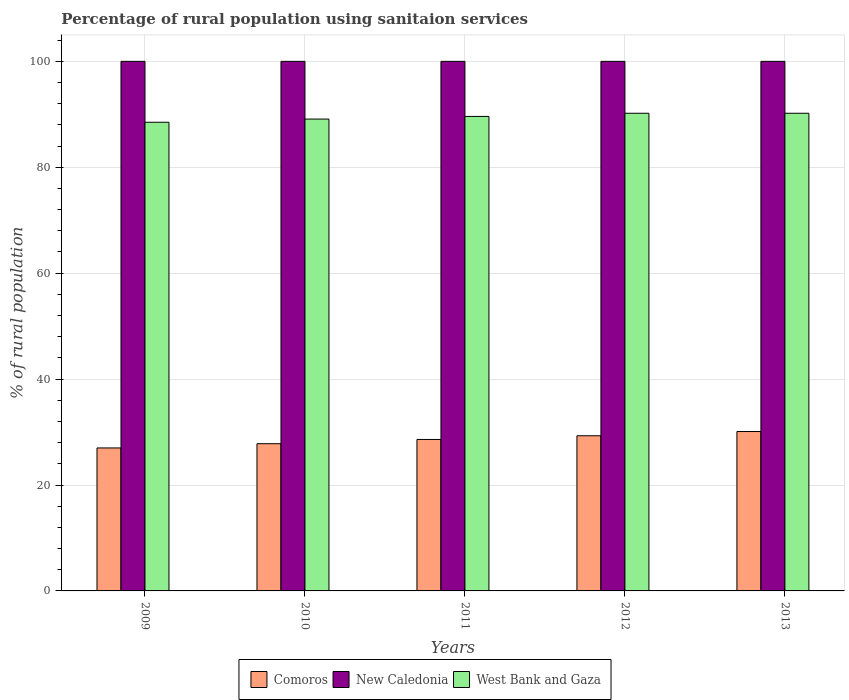Are the number of bars per tick equal to the number of legend labels?
Offer a terse response. Yes. How many bars are there on the 2nd tick from the right?
Offer a terse response. 3. In how many cases, is the number of bars for a given year not equal to the number of legend labels?
Your response must be concise. 0. What is the percentage of rural population using sanitaion services in New Caledonia in 2009?
Your response must be concise. 100. Across all years, what is the maximum percentage of rural population using sanitaion services in West Bank and Gaza?
Keep it short and to the point. 90.2. Across all years, what is the minimum percentage of rural population using sanitaion services in Comoros?
Provide a short and direct response. 27. In which year was the percentage of rural population using sanitaion services in West Bank and Gaza maximum?
Offer a very short reply. 2012. In which year was the percentage of rural population using sanitaion services in New Caledonia minimum?
Your response must be concise. 2009. What is the total percentage of rural population using sanitaion services in Comoros in the graph?
Provide a short and direct response. 142.8. What is the difference between the percentage of rural population using sanitaion services in Comoros in 2011 and that in 2012?
Offer a terse response. -0.7. What is the difference between the percentage of rural population using sanitaion services in Comoros in 2011 and the percentage of rural population using sanitaion services in West Bank and Gaza in 2013?
Give a very brief answer. -61.6. What is the average percentage of rural population using sanitaion services in West Bank and Gaza per year?
Offer a very short reply. 89.52. In the year 2013, what is the difference between the percentage of rural population using sanitaion services in New Caledonia and percentage of rural population using sanitaion services in West Bank and Gaza?
Provide a short and direct response. 9.8. In how many years, is the percentage of rural population using sanitaion services in Comoros greater than 80 %?
Ensure brevity in your answer.  0. What is the ratio of the percentage of rural population using sanitaion services in West Bank and Gaza in 2011 to that in 2013?
Offer a very short reply. 0.99. Is the percentage of rural population using sanitaion services in Comoros in 2010 less than that in 2013?
Keep it short and to the point. Yes. Is the difference between the percentage of rural population using sanitaion services in New Caledonia in 2011 and 2012 greater than the difference between the percentage of rural population using sanitaion services in West Bank and Gaza in 2011 and 2012?
Make the answer very short. Yes. What is the difference between the highest and the second highest percentage of rural population using sanitaion services in West Bank and Gaza?
Keep it short and to the point. 0. What is the difference between the highest and the lowest percentage of rural population using sanitaion services in Comoros?
Provide a succinct answer. 3.1. What does the 2nd bar from the left in 2010 represents?
Your answer should be compact. New Caledonia. What does the 3rd bar from the right in 2013 represents?
Ensure brevity in your answer.  Comoros. Is it the case that in every year, the sum of the percentage of rural population using sanitaion services in Comoros and percentage of rural population using sanitaion services in West Bank and Gaza is greater than the percentage of rural population using sanitaion services in New Caledonia?
Your answer should be very brief. Yes. How many bars are there?
Ensure brevity in your answer.  15. How many years are there in the graph?
Ensure brevity in your answer.  5. How many legend labels are there?
Your response must be concise. 3. How are the legend labels stacked?
Provide a succinct answer. Horizontal. What is the title of the graph?
Provide a succinct answer. Percentage of rural population using sanitaion services. Does "Korea (Republic)" appear as one of the legend labels in the graph?
Keep it short and to the point. No. What is the label or title of the Y-axis?
Make the answer very short. % of rural population. What is the % of rural population of New Caledonia in 2009?
Your answer should be very brief. 100. What is the % of rural population in West Bank and Gaza in 2009?
Ensure brevity in your answer.  88.5. What is the % of rural population of Comoros in 2010?
Keep it short and to the point. 27.8. What is the % of rural population of West Bank and Gaza in 2010?
Make the answer very short. 89.1. What is the % of rural population in Comoros in 2011?
Offer a terse response. 28.6. What is the % of rural population in New Caledonia in 2011?
Keep it short and to the point. 100. What is the % of rural population of West Bank and Gaza in 2011?
Provide a succinct answer. 89.6. What is the % of rural population in Comoros in 2012?
Offer a very short reply. 29.3. What is the % of rural population of New Caledonia in 2012?
Your response must be concise. 100. What is the % of rural population of West Bank and Gaza in 2012?
Ensure brevity in your answer.  90.2. What is the % of rural population of Comoros in 2013?
Keep it short and to the point. 30.1. What is the % of rural population of West Bank and Gaza in 2013?
Offer a very short reply. 90.2. Across all years, what is the maximum % of rural population of Comoros?
Give a very brief answer. 30.1. Across all years, what is the maximum % of rural population of New Caledonia?
Your answer should be compact. 100. Across all years, what is the maximum % of rural population of West Bank and Gaza?
Make the answer very short. 90.2. Across all years, what is the minimum % of rural population in Comoros?
Make the answer very short. 27. Across all years, what is the minimum % of rural population of New Caledonia?
Your answer should be very brief. 100. Across all years, what is the minimum % of rural population of West Bank and Gaza?
Make the answer very short. 88.5. What is the total % of rural population of Comoros in the graph?
Your answer should be very brief. 142.8. What is the total % of rural population of New Caledonia in the graph?
Keep it short and to the point. 500. What is the total % of rural population in West Bank and Gaza in the graph?
Your answer should be compact. 447.6. What is the difference between the % of rural population in Comoros in 2009 and that in 2010?
Keep it short and to the point. -0.8. What is the difference between the % of rural population in West Bank and Gaza in 2009 and that in 2010?
Provide a succinct answer. -0.6. What is the difference between the % of rural population of New Caledonia in 2009 and that in 2011?
Your answer should be compact. 0. What is the difference between the % of rural population of West Bank and Gaza in 2009 and that in 2011?
Provide a succinct answer. -1.1. What is the difference between the % of rural population in Comoros in 2009 and that in 2012?
Make the answer very short. -2.3. What is the difference between the % of rural population of Comoros in 2009 and that in 2013?
Offer a very short reply. -3.1. What is the difference between the % of rural population of New Caledonia in 2009 and that in 2013?
Provide a short and direct response. 0. What is the difference between the % of rural population of West Bank and Gaza in 2009 and that in 2013?
Your answer should be very brief. -1.7. What is the difference between the % of rural population of New Caledonia in 2010 and that in 2011?
Provide a succinct answer. 0. What is the difference between the % of rural population of West Bank and Gaza in 2010 and that in 2011?
Give a very brief answer. -0.5. What is the difference between the % of rural population in Comoros in 2010 and that in 2012?
Offer a very short reply. -1.5. What is the difference between the % of rural population in West Bank and Gaza in 2010 and that in 2012?
Keep it short and to the point. -1.1. What is the difference between the % of rural population in New Caledonia in 2010 and that in 2013?
Make the answer very short. 0. What is the difference between the % of rural population of West Bank and Gaza in 2011 and that in 2012?
Your response must be concise. -0.6. What is the difference between the % of rural population of West Bank and Gaza in 2011 and that in 2013?
Offer a terse response. -0.6. What is the difference between the % of rural population of Comoros in 2009 and the % of rural population of New Caledonia in 2010?
Your answer should be very brief. -73. What is the difference between the % of rural population in Comoros in 2009 and the % of rural population in West Bank and Gaza in 2010?
Keep it short and to the point. -62.1. What is the difference between the % of rural population in New Caledonia in 2009 and the % of rural population in West Bank and Gaza in 2010?
Provide a short and direct response. 10.9. What is the difference between the % of rural population of Comoros in 2009 and the % of rural population of New Caledonia in 2011?
Your answer should be very brief. -73. What is the difference between the % of rural population of Comoros in 2009 and the % of rural population of West Bank and Gaza in 2011?
Keep it short and to the point. -62.6. What is the difference between the % of rural population in Comoros in 2009 and the % of rural population in New Caledonia in 2012?
Keep it short and to the point. -73. What is the difference between the % of rural population of Comoros in 2009 and the % of rural population of West Bank and Gaza in 2012?
Offer a very short reply. -63.2. What is the difference between the % of rural population of New Caledonia in 2009 and the % of rural population of West Bank and Gaza in 2012?
Your answer should be very brief. 9.8. What is the difference between the % of rural population in Comoros in 2009 and the % of rural population in New Caledonia in 2013?
Give a very brief answer. -73. What is the difference between the % of rural population of Comoros in 2009 and the % of rural population of West Bank and Gaza in 2013?
Your response must be concise. -63.2. What is the difference between the % of rural population of New Caledonia in 2009 and the % of rural population of West Bank and Gaza in 2013?
Ensure brevity in your answer.  9.8. What is the difference between the % of rural population of Comoros in 2010 and the % of rural population of New Caledonia in 2011?
Offer a very short reply. -72.2. What is the difference between the % of rural population of Comoros in 2010 and the % of rural population of West Bank and Gaza in 2011?
Offer a very short reply. -61.8. What is the difference between the % of rural population in Comoros in 2010 and the % of rural population in New Caledonia in 2012?
Ensure brevity in your answer.  -72.2. What is the difference between the % of rural population of Comoros in 2010 and the % of rural population of West Bank and Gaza in 2012?
Your answer should be very brief. -62.4. What is the difference between the % of rural population of Comoros in 2010 and the % of rural population of New Caledonia in 2013?
Provide a succinct answer. -72.2. What is the difference between the % of rural population in Comoros in 2010 and the % of rural population in West Bank and Gaza in 2013?
Your answer should be compact. -62.4. What is the difference between the % of rural population of Comoros in 2011 and the % of rural population of New Caledonia in 2012?
Your answer should be very brief. -71.4. What is the difference between the % of rural population of Comoros in 2011 and the % of rural population of West Bank and Gaza in 2012?
Make the answer very short. -61.6. What is the difference between the % of rural population in Comoros in 2011 and the % of rural population in New Caledonia in 2013?
Ensure brevity in your answer.  -71.4. What is the difference between the % of rural population in Comoros in 2011 and the % of rural population in West Bank and Gaza in 2013?
Provide a succinct answer. -61.6. What is the difference between the % of rural population of New Caledonia in 2011 and the % of rural population of West Bank and Gaza in 2013?
Provide a succinct answer. 9.8. What is the difference between the % of rural population of Comoros in 2012 and the % of rural population of New Caledonia in 2013?
Give a very brief answer. -70.7. What is the difference between the % of rural population of Comoros in 2012 and the % of rural population of West Bank and Gaza in 2013?
Make the answer very short. -60.9. What is the difference between the % of rural population in New Caledonia in 2012 and the % of rural population in West Bank and Gaza in 2013?
Offer a terse response. 9.8. What is the average % of rural population in Comoros per year?
Keep it short and to the point. 28.56. What is the average % of rural population in West Bank and Gaza per year?
Keep it short and to the point. 89.52. In the year 2009, what is the difference between the % of rural population in Comoros and % of rural population in New Caledonia?
Provide a short and direct response. -73. In the year 2009, what is the difference between the % of rural population in Comoros and % of rural population in West Bank and Gaza?
Your answer should be compact. -61.5. In the year 2009, what is the difference between the % of rural population of New Caledonia and % of rural population of West Bank and Gaza?
Give a very brief answer. 11.5. In the year 2010, what is the difference between the % of rural population in Comoros and % of rural population in New Caledonia?
Offer a terse response. -72.2. In the year 2010, what is the difference between the % of rural population of Comoros and % of rural population of West Bank and Gaza?
Offer a terse response. -61.3. In the year 2011, what is the difference between the % of rural population in Comoros and % of rural population in New Caledonia?
Offer a very short reply. -71.4. In the year 2011, what is the difference between the % of rural population in Comoros and % of rural population in West Bank and Gaza?
Give a very brief answer. -61. In the year 2011, what is the difference between the % of rural population of New Caledonia and % of rural population of West Bank and Gaza?
Provide a short and direct response. 10.4. In the year 2012, what is the difference between the % of rural population of Comoros and % of rural population of New Caledonia?
Your response must be concise. -70.7. In the year 2012, what is the difference between the % of rural population of Comoros and % of rural population of West Bank and Gaza?
Offer a terse response. -60.9. In the year 2013, what is the difference between the % of rural population in Comoros and % of rural population in New Caledonia?
Keep it short and to the point. -69.9. In the year 2013, what is the difference between the % of rural population of Comoros and % of rural population of West Bank and Gaza?
Keep it short and to the point. -60.1. What is the ratio of the % of rural population of Comoros in 2009 to that in 2010?
Your answer should be very brief. 0.97. What is the ratio of the % of rural population in New Caledonia in 2009 to that in 2010?
Offer a terse response. 1. What is the ratio of the % of rural population of West Bank and Gaza in 2009 to that in 2010?
Make the answer very short. 0.99. What is the ratio of the % of rural population of Comoros in 2009 to that in 2011?
Provide a short and direct response. 0.94. What is the ratio of the % of rural population of Comoros in 2009 to that in 2012?
Offer a very short reply. 0.92. What is the ratio of the % of rural population of New Caledonia in 2009 to that in 2012?
Keep it short and to the point. 1. What is the ratio of the % of rural population in West Bank and Gaza in 2009 to that in 2012?
Make the answer very short. 0.98. What is the ratio of the % of rural population in Comoros in 2009 to that in 2013?
Give a very brief answer. 0.9. What is the ratio of the % of rural population in West Bank and Gaza in 2009 to that in 2013?
Offer a very short reply. 0.98. What is the ratio of the % of rural population of New Caledonia in 2010 to that in 2011?
Make the answer very short. 1. What is the ratio of the % of rural population of Comoros in 2010 to that in 2012?
Provide a succinct answer. 0.95. What is the ratio of the % of rural population in West Bank and Gaza in 2010 to that in 2012?
Provide a succinct answer. 0.99. What is the ratio of the % of rural population of Comoros in 2010 to that in 2013?
Give a very brief answer. 0.92. What is the ratio of the % of rural population in West Bank and Gaza in 2010 to that in 2013?
Provide a succinct answer. 0.99. What is the ratio of the % of rural population in Comoros in 2011 to that in 2012?
Give a very brief answer. 0.98. What is the ratio of the % of rural population in West Bank and Gaza in 2011 to that in 2012?
Keep it short and to the point. 0.99. What is the ratio of the % of rural population in Comoros in 2011 to that in 2013?
Make the answer very short. 0.95. What is the ratio of the % of rural population in New Caledonia in 2011 to that in 2013?
Your answer should be compact. 1. What is the ratio of the % of rural population in West Bank and Gaza in 2011 to that in 2013?
Ensure brevity in your answer.  0.99. What is the ratio of the % of rural population of Comoros in 2012 to that in 2013?
Offer a very short reply. 0.97. What is the ratio of the % of rural population of New Caledonia in 2012 to that in 2013?
Your answer should be very brief. 1. What is the difference between the highest and the second highest % of rural population of Comoros?
Provide a short and direct response. 0.8. What is the difference between the highest and the second highest % of rural population in New Caledonia?
Your response must be concise. 0. 